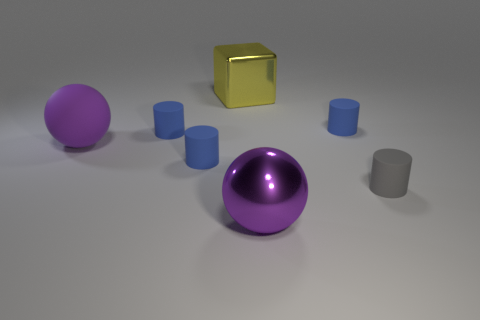How many large objects are either blue matte objects or yellow matte cubes?
Provide a succinct answer. 0. There is a ball that is behind the gray object; does it have the same size as the gray cylinder?
Your response must be concise. No. What number of other things are there of the same color as the large shiny ball?
Provide a succinct answer. 1. What material is the big yellow block?
Provide a succinct answer. Metal. There is a large object that is both behind the gray object and in front of the yellow cube; what is its material?
Your response must be concise. Rubber. How many things are either big balls to the right of the yellow thing or metallic blocks?
Your answer should be compact. 2. Do the large matte sphere and the big metal sphere have the same color?
Offer a terse response. Yes. Is there a metallic thing that has the same size as the yellow metallic block?
Ensure brevity in your answer.  Yes. How many objects are both behind the large rubber object and in front of the big yellow thing?
Offer a very short reply. 2. How many big things are left of the large yellow metal cube?
Your answer should be very brief. 1. 